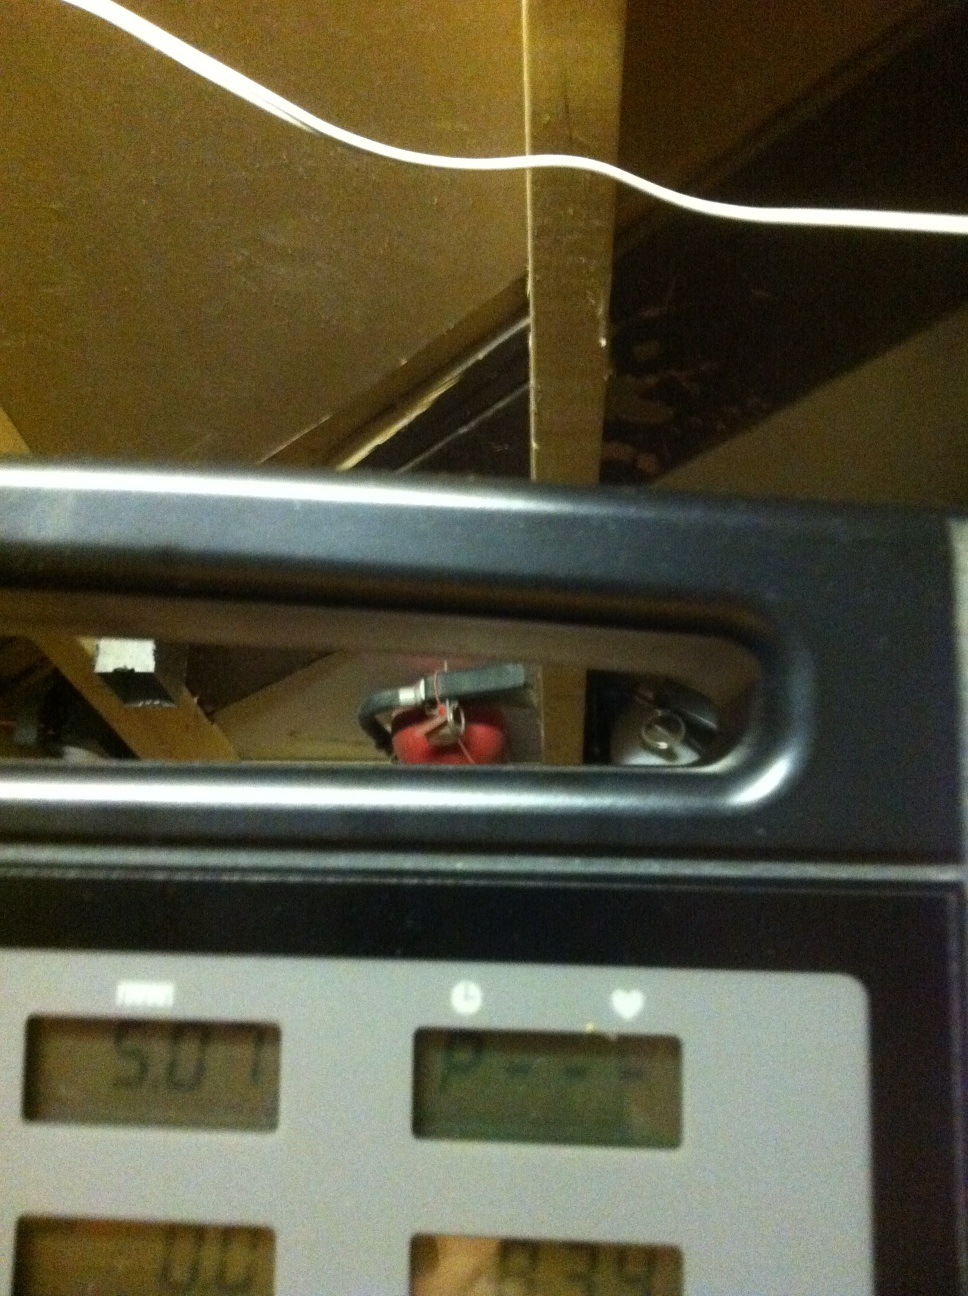What realistic scenarios could occur in the room shown in the image while using the treadmill? In a realistic scenario, the treadmill user might be keeping a consistent pace to meet a daily goal while listening to music or an audio book. The presence of the fire extinguisher ensures that in case of an emergency like an electrical fire, there’s a safety measure available. What else can you fit into this environment to make a full home gym? To convert this environment into a full home gym, you could add additional equipment such as a set of free weights, a yoga mat, resistance bands, and stability balls. An adjustable bench, a stationary bike, a rower, and a pull-up bar could also be included. Mirror installations, a television, or a sound system to play workout videos or music would further enhance the workout experience. Proper lighting and ventilation, effective storage solutions for equipment, and even some indoor plants could make the space more inviting and functional. 